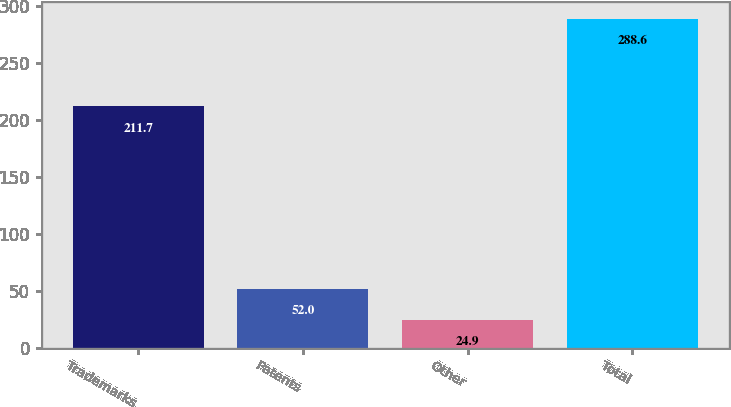Convert chart. <chart><loc_0><loc_0><loc_500><loc_500><bar_chart><fcel>Trademarks<fcel>Patents<fcel>Other<fcel>Total<nl><fcel>211.7<fcel>52<fcel>24.9<fcel>288.6<nl></chart> 